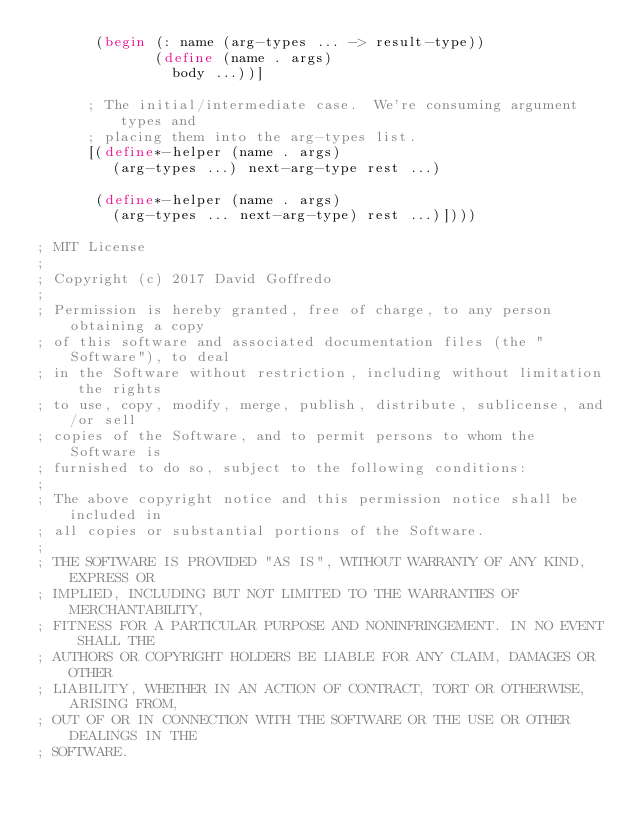<code> <loc_0><loc_0><loc_500><loc_500><_Scheme_>       (begin (: name (arg-types ... -> result-type))
              (define (name . args)
                body ...))]
  
      ; The initial/intermediate case.  We're consuming argument types and
      ; placing them into the arg-types list.
      [(define*-helper (name . args)
         (arg-types ...) next-arg-type rest ...)
  
       (define*-helper (name . args)
         (arg-types ... next-arg-type) rest ...)])))

; MIT License
; 
; Copyright (c) 2017 David Goffredo
; 
; Permission is hereby granted, free of charge, to any person obtaining a copy
; of this software and associated documentation files (the "Software"), to deal
; in the Software without restriction, including without limitation the rights
; to use, copy, modify, merge, publish, distribute, sublicense, and/or sell
; copies of the Software, and to permit persons to whom the Software is
; furnished to do so, subject to the following conditions:
; 
; The above copyright notice and this permission notice shall be included in
; all copies or substantial portions of the Software.
; 
; THE SOFTWARE IS PROVIDED "AS IS", WITHOUT WARRANTY OF ANY KIND, EXPRESS OR
; IMPLIED, INCLUDING BUT NOT LIMITED TO THE WARRANTIES OF MERCHANTABILITY,
; FITNESS FOR A PARTICULAR PURPOSE AND NONINFRINGEMENT. IN NO EVENT SHALL THE
; AUTHORS OR COPYRIGHT HOLDERS BE LIABLE FOR ANY CLAIM, DAMAGES OR OTHER
; LIABILITY, WHETHER IN AN ACTION OF CONTRACT, TORT OR OTHERWISE, ARISING FROM,
; OUT OF OR IN CONNECTION WITH THE SOFTWARE OR THE USE OR OTHER DEALINGS IN THE
; SOFTWARE.
</code> 